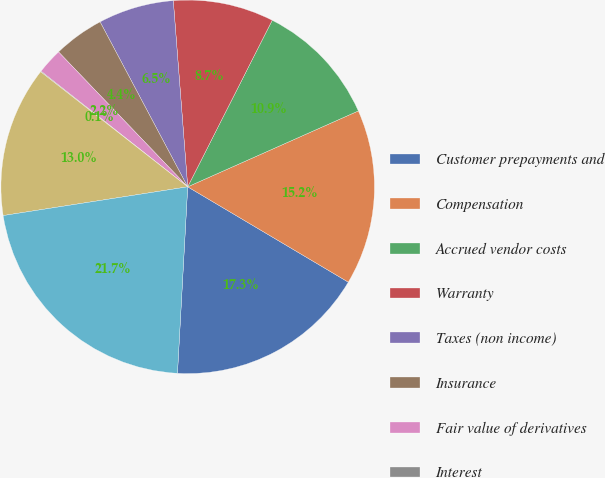Convert chart to OTSL. <chart><loc_0><loc_0><loc_500><loc_500><pie_chart><fcel>Customer prepayments and<fcel>Compensation<fcel>Accrued vendor costs<fcel>Warranty<fcel>Taxes (non income)<fcel>Insurance<fcel>Fair value of derivatives<fcel>Interest<fcel>Other<fcel>Total<nl><fcel>17.34%<fcel>15.18%<fcel>10.86%<fcel>8.7%<fcel>6.54%<fcel>4.38%<fcel>2.22%<fcel>0.06%<fcel>13.02%<fcel>21.66%<nl></chart> 